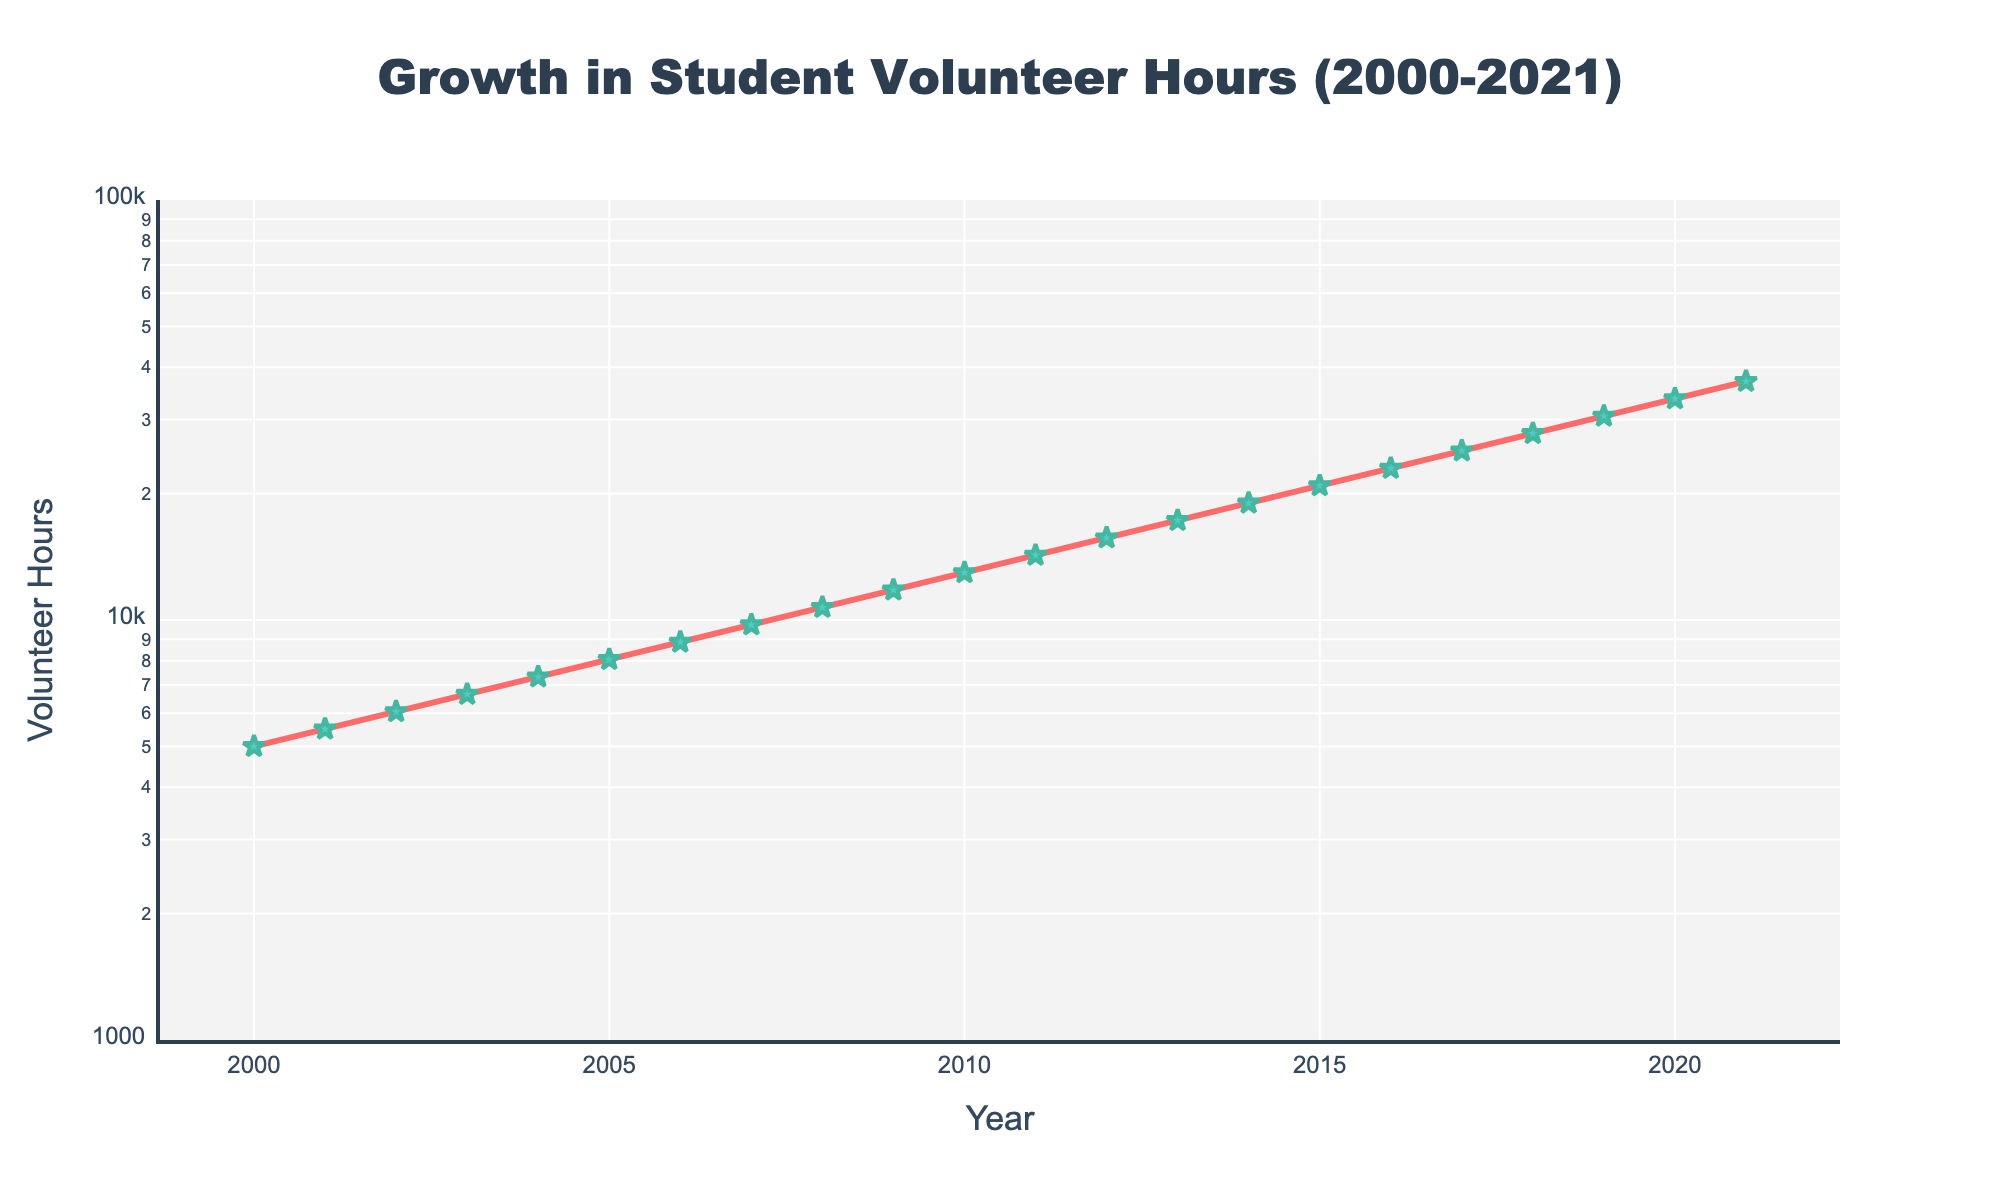what is the title of the plot? The title of the plot is prominently displayed at the top and reads "Growth in Student Volunteer Hours (2000-2021)"
Answer: Growth in Student Volunteer Hours (2000-2021) how many data points are there in the plot? Each year from 2000 to 2021 represents a data point, so counting these gives us 22 data points.
Answer: 22 what is the approximate range of volunteer hours in the plot? The y-axis uses a logarithmic scale and ranges from roughly 1,000 to 100,000 volunteer hours, as indicated by the axis range settings.
Answer: 1,000 to 100,000 how does the volunteer hour value in 2010 compare to that in 2000? From the plot, the volunteer hours in 2010 (12,966) are significantly higher than in 2000 (5,000).
Answer: Higher which year saw the highest number of volunteer hours? The last data point in the plot, representing the year 2021, has the highest number of volunteer hours at 36,993.
Answer: 2021 what is the difference in volunteer hours between 2005 and 2010? Volunteer hours in 2005 are 8,052 and in 2010 are 12,966. Subtracting these gives a difference of 4,914 hours.
Answer: 4,914 describe the trend in volunteer hours from 2000 to 2021. The general trend from 2000 to 2021 shows a steady and exponential increase in volunteer hours over the years, as indicated by an upward-sloping line on the log scale.
Answer: Steady exponential increase what is the percentage increase in volunteer hours from 2015 to 2020? In 2015, volunteer hours are 20,882, and in 2020, they are 33,630. Calculate the increase (33,630 - 20,882 = 12,748), then the percentage increase (12,748 / 20,882 * 100 ≈ 61%).
Answer: ~61% which year has a volunteer hour count closest to 10,000? In 2008, the volunteer hours are 10,716, the closest count to 10,000.
Answer: 2008 do the volunteer hours growth appear to follow a linear or exponential trend? Given the logarithmic y-axis and the shape of the curve, the trend in volunteer hours appears exponential, as the line represents a steady increasing pattern on the log scale.
Answer: Exponential 